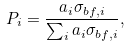<formula> <loc_0><loc_0><loc_500><loc_500>P _ { i } = \frac { a _ { i } \sigma _ { b f , i } } { \sum _ { i } a _ { i } \sigma _ { b f , i } } ,</formula> 